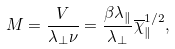Convert formula to latex. <formula><loc_0><loc_0><loc_500><loc_500>M = \frac { V } { \lambda _ { \perp } \nu } = \frac { \beta \lambda _ { \| } } { \lambda _ { \perp } } \overline { \chi } _ { \| } ^ { 1 / 2 } ,</formula> 